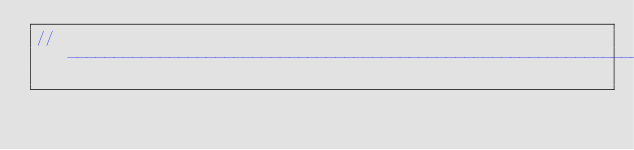<code> <loc_0><loc_0><loc_500><loc_500><_C++_>//-----------------------------------------------------------------------------------</code> 